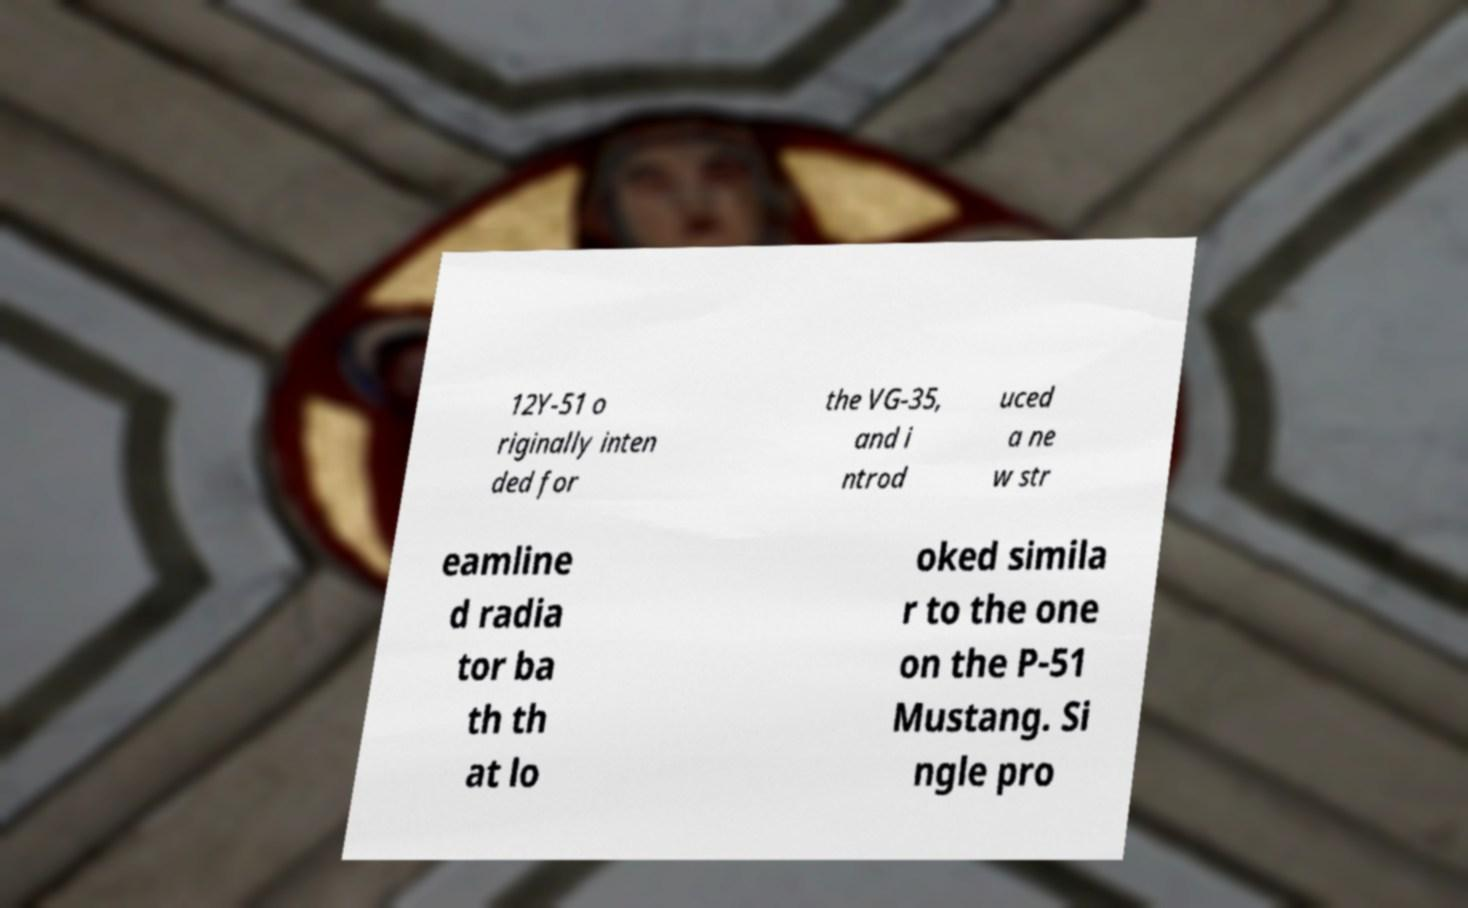Please read and relay the text visible in this image. What does it say? 12Y-51 o riginally inten ded for the VG-35, and i ntrod uced a ne w str eamline d radia tor ba th th at lo oked simila r to the one on the P-51 Mustang. Si ngle pro 